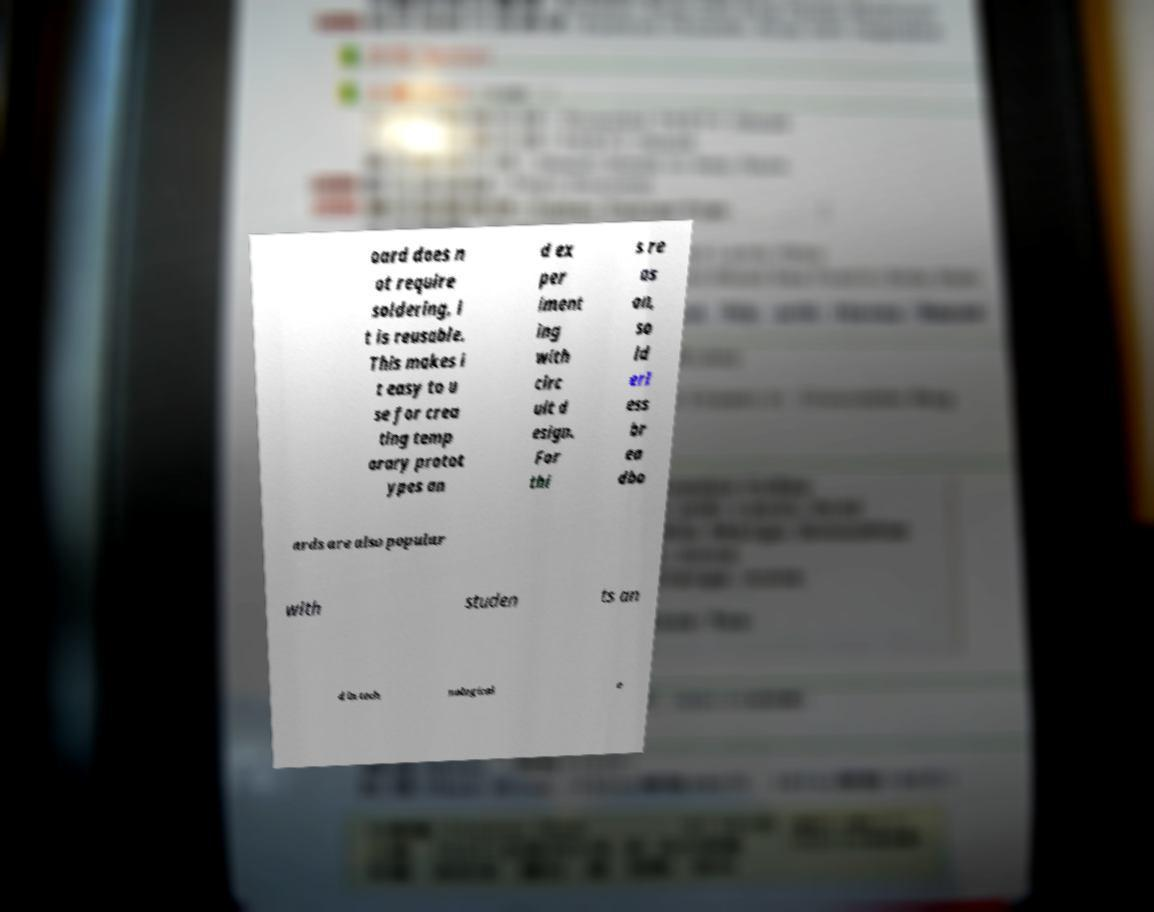Can you read and provide the text displayed in the image?This photo seems to have some interesting text. Can you extract and type it out for me? oard does n ot require soldering, i t is reusable. This makes i t easy to u se for crea ting temp orary protot ypes an d ex per iment ing with circ uit d esign. For thi s re as on, so ld erl ess br ea dbo ards are also popular with studen ts an d in tech nological e 